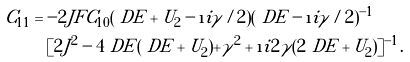Convert formula to latex. <formula><loc_0><loc_0><loc_500><loc_500>C _ { 1 1 } & = - 2 J F C _ { 1 0 } ( \ D E + U _ { 2 } - \i i \gamma / 2 ) ( \ D E - \i i \gamma / 2 ) ^ { - 1 } \\ & \quad [ 2 J ^ { 2 } - 4 \ D E ( \ D E + U _ { 2 } ) + \gamma ^ { 2 } + \i i 2 \gamma ( 2 \ D E + U _ { 2 } ) ] ^ { - 1 } .</formula> 